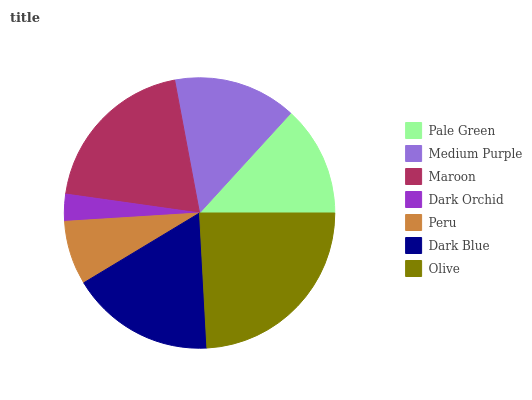Is Dark Orchid the minimum?
Answer yes or no. Yes. Is Olive the maximum?
Answer yes or no. Yes. Is Medium Purple the minimum?
Answer yes or no. No. Is Medium Purple the maximum?
Answer yes or no. No. Is Medium Purple greater than Pale Green?
Answer yes or no. Yes. Is Pale Green less than Medium Purple?
Answer yes or no. Yes. Is Pale Green greater than Medium Purple?
Answer yes or no. No. Is Medium Purple less than Pale Green?
Answer yes or no. No. Is Medium Purple the high median?
Answer yes or no. Yes. Is Medium Purple the low median?
Answer yes or no. Yes. Is Peru the high median?
Answer yes or no. No. Is Dark Blue the low median?
Answer yes or no. No. 